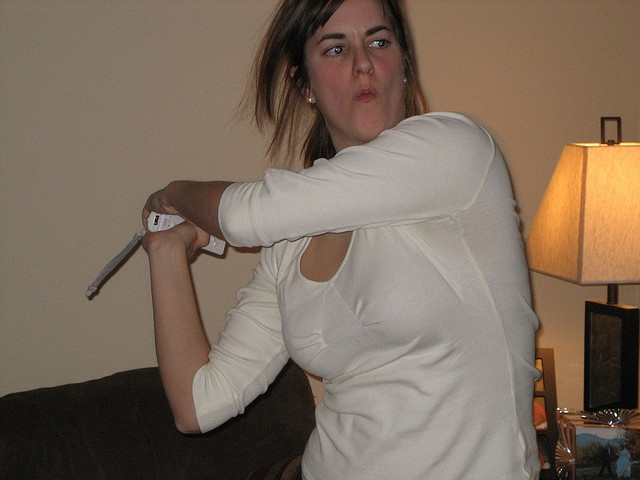Describe the objects in this image and their specific colors. I can see people in gray, darkgray, and black tones, couch in gray and black tones, and remote in gray tones in this image. 